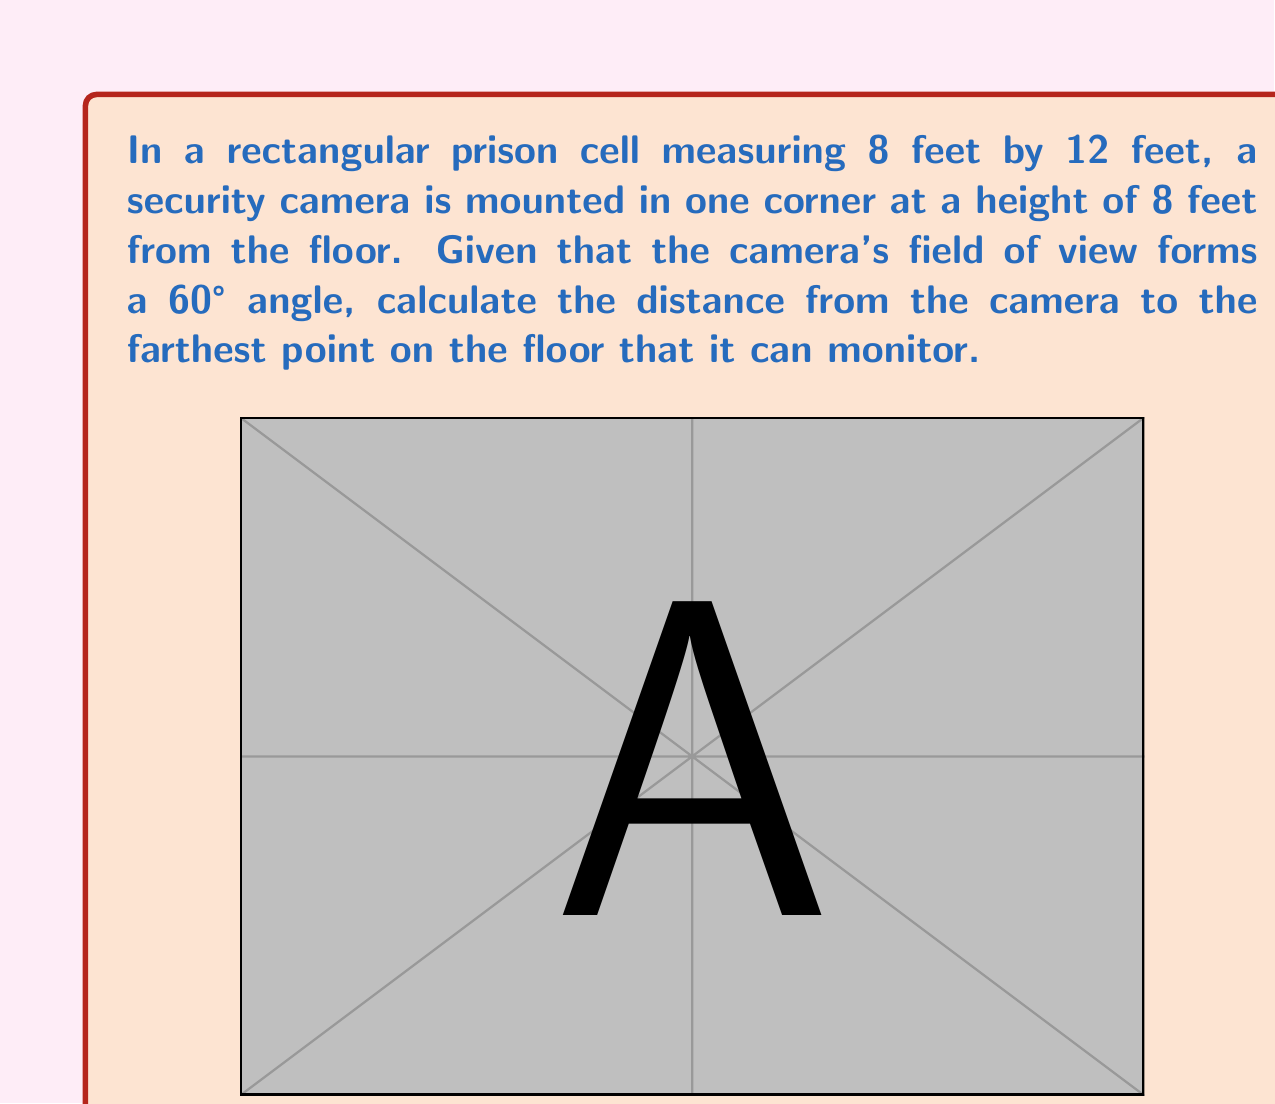Can you solve this math problem? Let's approach this step-by-step:

1) First, we need to understand the geometry of the situation. The camera forms a cone of vision with a 60° angle at its apex.

2) The farthest point on the floor will be at the opposite corner of the cell from where the camera is mounted.

3) We can treat this as a right triangle problem, where:
   - The height of the camera (8 feet) is one side of the triangle
   - The diagonal of the floor is the base of the triangle
   - The line of sight from the camera to the farthest point is the hypotenuse

4) Let's calculate the diagonal of the floor using the Pythagorean theorem:

   $$d = \sqrt{8^2 + 12^2} = \sqrt{64 + 144} = \sqrt{208} = 4\sqrt{13} \text{ feet}$$

5) Now we have a right triangle with:
   - Adjacent side (height) = 8 feet
   - Opposite side (diagonal) = $4\sqrt{13}$ feet
   - Angle at the top = 30° (half of the 60° field of view)

6) We can use the tangent function to find the relationship between these:

   $$\tan 30° = \frac{\text{opposite}}{\text{adjacent}} = \frac{4\sqrt{13}}{8}$$

7) We know that $\tan 30° = \frac{1}{\sqrt{3}}$, so:

   $$\frac{1}{\sqrt{3}} = \frac{4\sqrt{13}}{8}$$

8) Cross-multiplying:

   $$8 = 4\sqrt{13}\sqrt{3}$$

9) Squaring both sides:

   $$64 = 48 \cdot 13$$

10) The distance we're looking for is the hypotenuse of this triangle. We can find it using the Pythagorean theorem:

    $$\text{distance}^2 = 8^2 + (4\sqrt{13})^2 = 64 + 208 = 272$$

11) Taking the square root:

    $$\text{distance} = \sqrt{272} = 4\sqrt{17} \text{ feet}$$
Answer: $4\sqrt{17}$ feet 